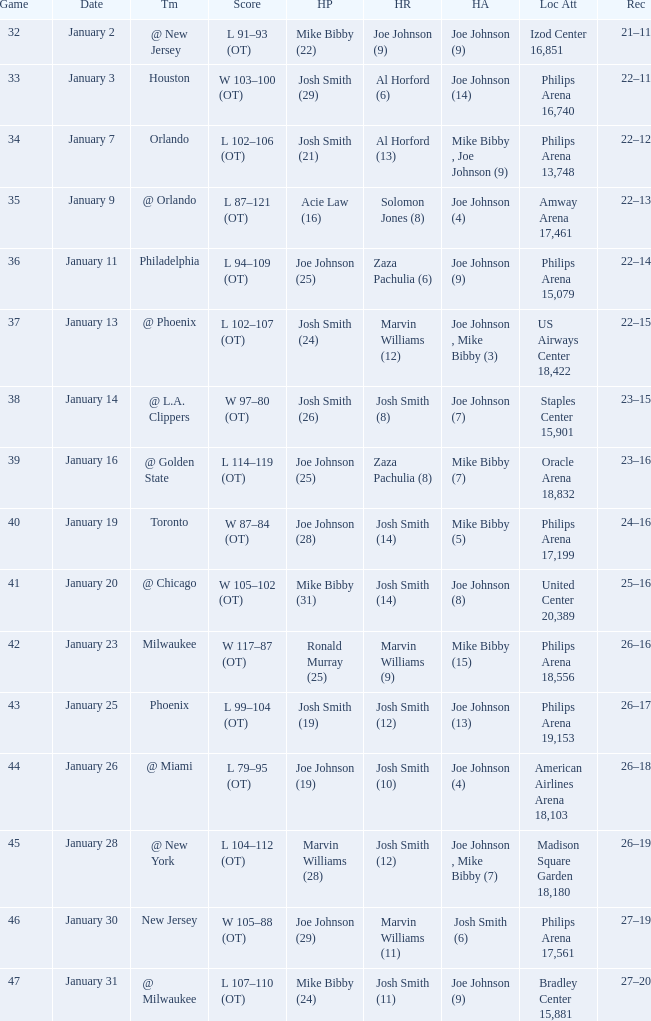Which date was game 35 on? January 9. Parse the table in full. {'header': ['Game', 'Date', 'Tm', 'Score', 'HP', 'HR', 'HA', 'Loc Att', 'Rec'], 'rows': [['32', 'January 2', '@ New Jersey', 'L 91–93 (OT)', 'Mike Bibby (22)', 'Joe Johnson (9)', 'Joe Johnson (9)', 'Izod Center 16,851', '21–11'], ['33', 'January 3', 'Houston', 'W 103–100 (OT)', 'Josh Smith (29)', 'Al Horford (6)', 'Joe Johnson (14)', 'Philips Arena 16,740', '22–11'], ['34', 'January 7', 'Orlando', 'L 102–106 (OT)', 'Josh Smith (21)', 'Al Horford (13)', 'Mike Bibby , Joe Johnson (9)', 'Philips Arena 13,748', '22–12'], ['35', 'January 9', '@ Orlando', 'L 87–121 (OT)', 'Acie Law (16)', 'Solomon Jones (8)', 'Joe Johnson (4)', 'Amway Arena 17,461', '22–13'], ['36', 'January 11', 'Philadelphia', 'L 94–109 (OT)', 'Joe Johnson (25)', 'Zaza Pachulia (6)', 'Joe Johnson (9)', 'Philips Arena 15,079', '22–14'], ['37', 'January 13', '@ Phoenix', 'L 102–107 (OT)', 'Josh Smith (24)', 'Marvin Williams (12)', 'Joe Johnson , Mike Bibby (3)', 'US Airways Center 18,422', '22–15'], ['38', 'January 14', '@ L.A. Clippers', 'W 97–80 (OT)', 'Josh Smith (26)', 'Josh Smith (8)', 'Joe Johnson (7)', 'Staples Center 15,901', '23–15'], ['39', 'January 16', '@ Golden State', 'L 114–119 (OT)', 'Joe Johnson (25)', 'Zaza Pachulia (8)', 'Mike Bibby (7)', 'Oracle Arena 18,832', '23–16'], ['40', 'January 19', 'Toronto', 'W 87–84 (OT)', 'Joe Johnson (28)', 'Josh Smith (14)', 'Mike Bibby (5)', 'Philips Arena 17,199', '24–16'], ['41', 'January 20', '@ Chicago', 'W 105–102 (OT)', 'Mike Bibby (31)', 'Josh Smith (14)', 'Joe Johnson (8)', 'United Center 20,389', '25–16'], ['42', 'January 23', 'Milwaukee', 'W 117–87 (OT)', 'Ronald Murray (25)', 'Marvin Williams (9)', 'Mike Bibby (15)', 'Philips Arena 18,556', '26–16'], ['43', 'January 25', 'Phoenix', 'L 99–104 (OT)', 'Josh Smith (19)', 'Josh Smith (12)', 'Joe Johnson (13)', 'Philips Arena 19,153', '26–17'], ['44', 'January 26', '@ Miami', 'L 79–95 (OT)', 'Joe Johnson (19)', 'Josh Smith (10)', 'Joe Johnson (4)', 'American Airlines Arena 18,103', '26–18'], ['45', 'January 28', '@ New York', 'L 104–112 (OT)', 'Marvin Williams (28)', 'Josh Smith (12)', 'Joe Johnson , Mike Bibby (7)', 'Madison Square Garden 18,180', '26–19'], ['46', 'January 30', 'New Jersey', 'W 105–88 (OT)', 'Joe Johnson (29)', 'Marvin Williams (11)', 'Josh Smith (6)', 'Philips Arena 17,561', '27–19'], ['47', 'January 31', '@ Milwaukee', 'L 107–110 (OT)', 'Mike Bibby (24)', 'Josh Smith (11)', 'Joe Johnson (9)', 'Bradley Center 15,881', '27–20']]} 